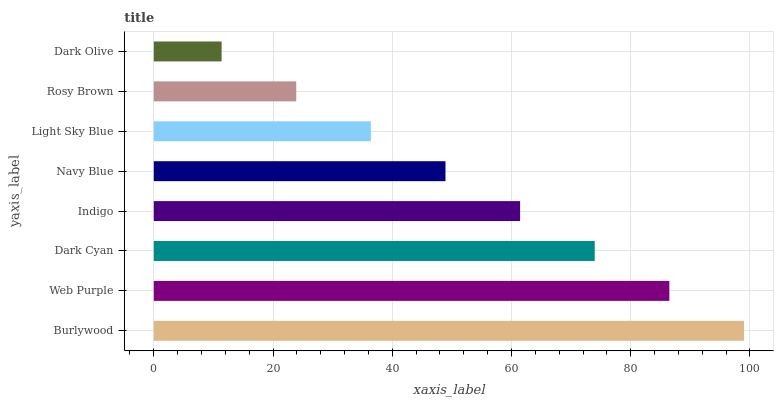Is Dark Olive the minimum?
Answer yes or no. Yes. Is Burlywood the maximum?
Answer yes or no. Yes. Is Web Purple the minimum?
Answer yes or no. No. Is Web Purple the maximum?
Answer yes or no. No. Is Burlywood greater than Web Purple?
Answer yes or no. Yes. Is Web Purple less than Burlywood?
Answer yes or no. Yes. Is Web Purple greater than Burlywood?
Answer yes or no. No. Is Burlywood less than Web Purple?
Answer yes or no. No. Is Indigo the high median?
Answer yes or no. Yes. Is Navy Blue the low median?
Answer yes or no. Yes. Is Navy Blue the high median?
Answer yes or no. No. Is Burlywood the low median?
Answer yes or no. No. 